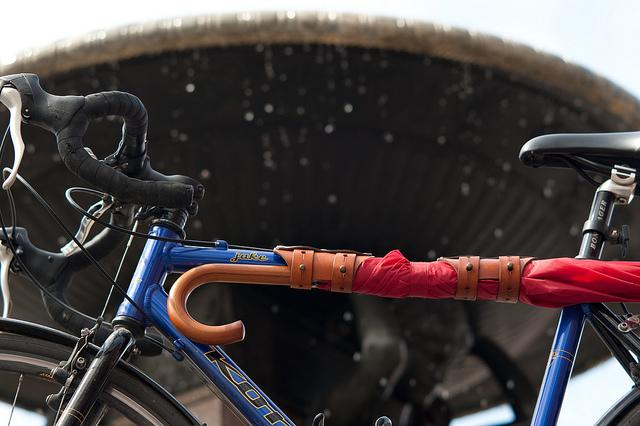The cyclist is most prepared for which weather today? rain 